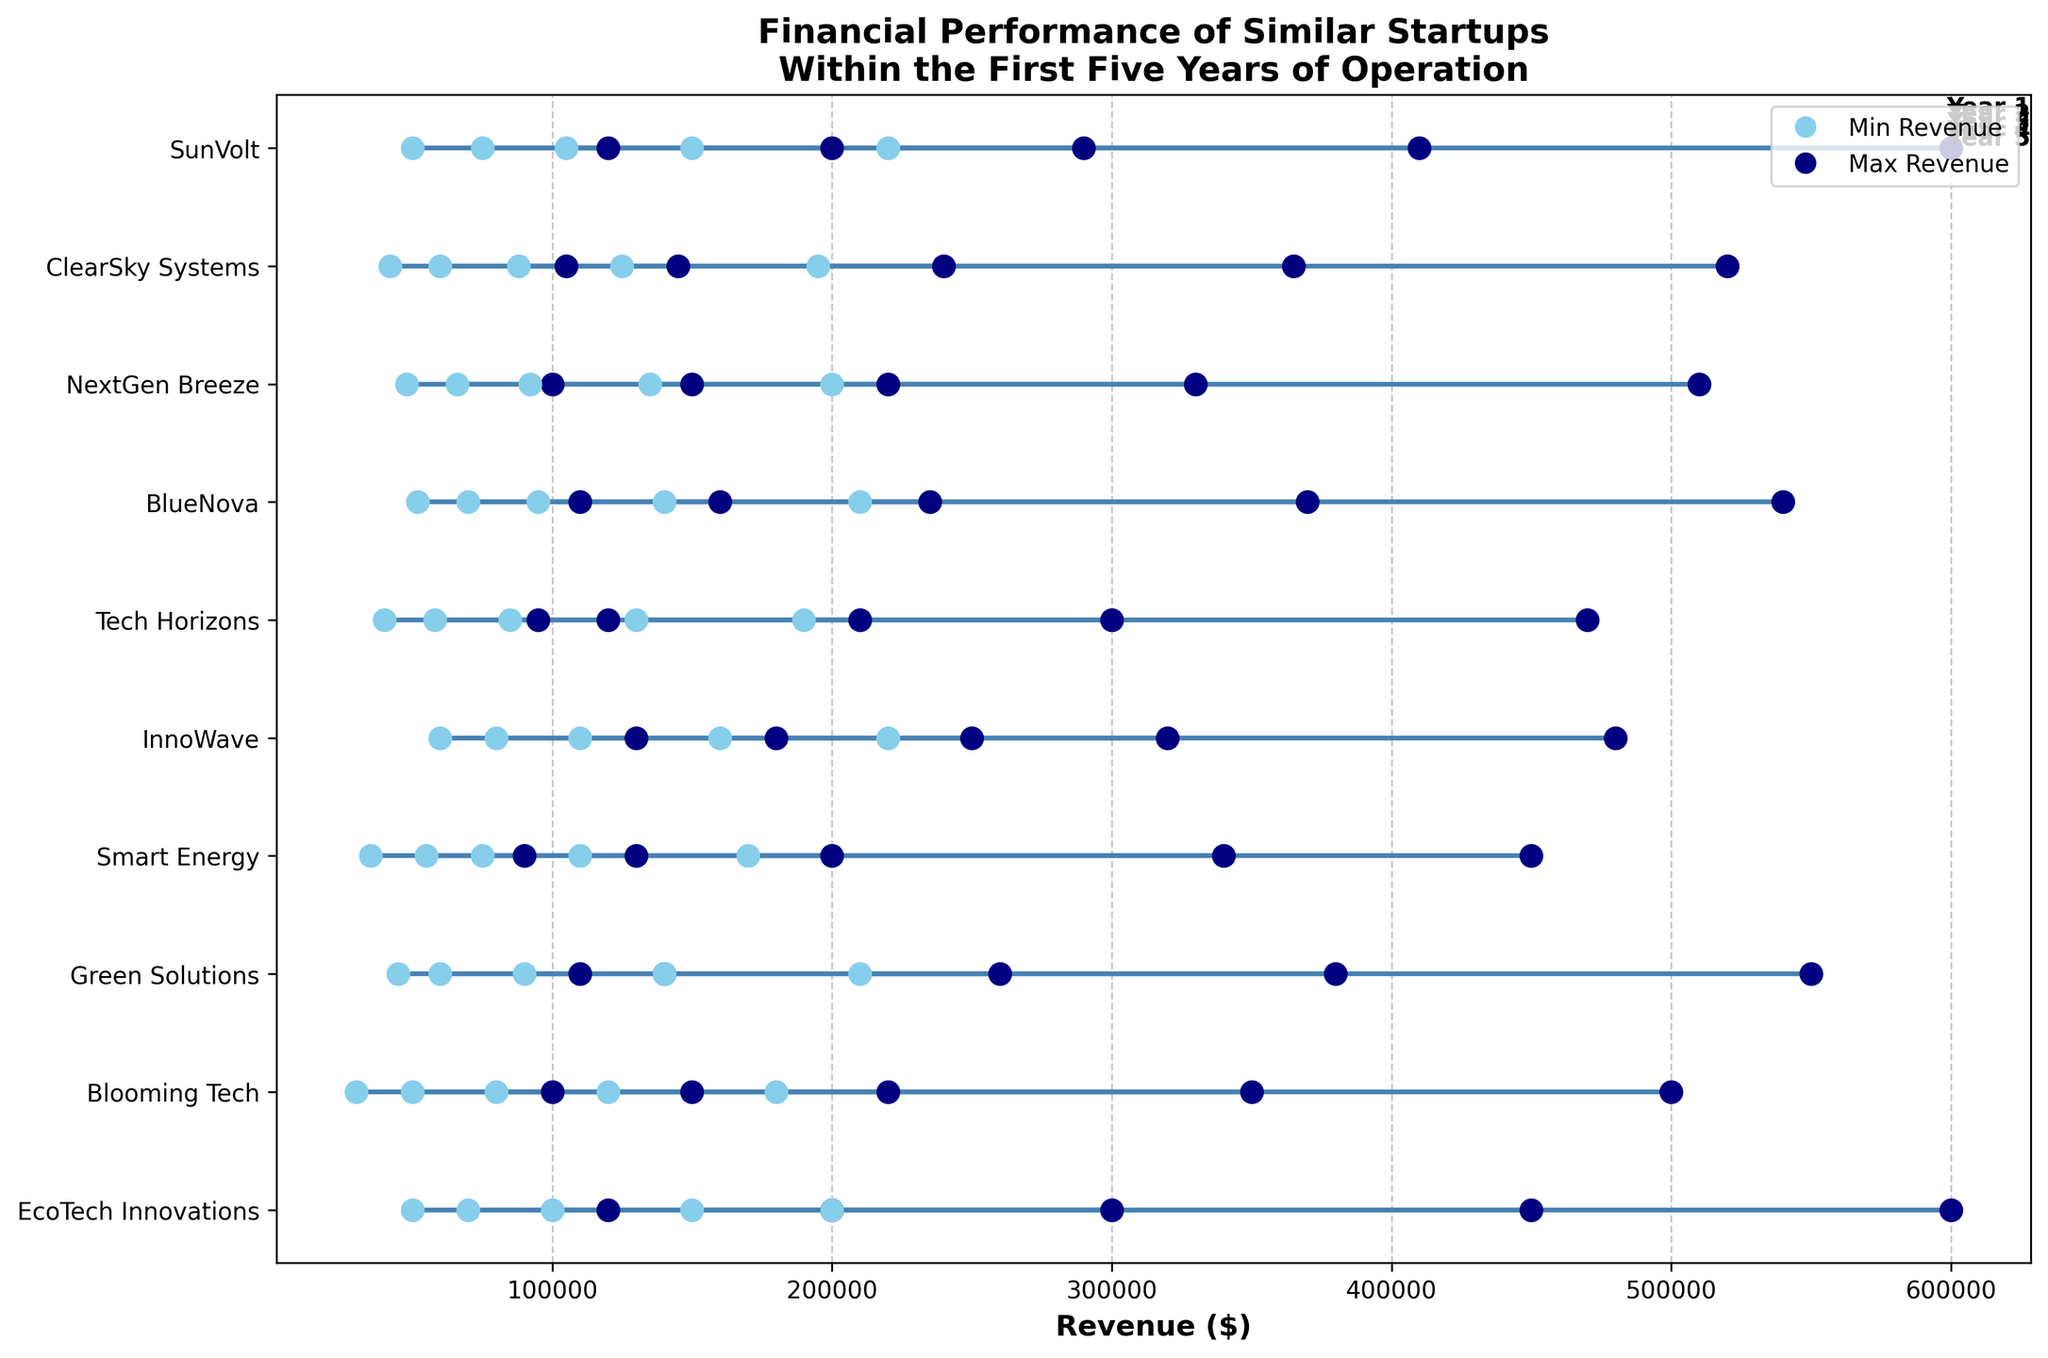what is the title of the plot? The title of the plot can be found at the top. It reads "Financial Performance of Similar Startups Within the First Five Years of Operation"
Answer: Financial Performance of Similar Startups Within the First Five Years of Operation Which startup has the highest range of revenue in Year 3? Look for the largest difference between the min and max dot placements in Year 3. For EcoTech Innovations, it ranges between $100,000 and $300,000. EcoTech Innovations has the highest range of $200,000.
Answer: EcoTech Innovations What is the minimum revenue of Smart Energy in Year 1? Identify the position of Smart Energy in the y-axis, then look for the smallest dot in Year 1 which is $35,000.
Answer: $35,000 Compare the maximum revenue in Year 2 for BlueNova and SunVolt. Which is higher? Look at Year 2 dots labeled for BlueNova and SunVolt, compare their maximum values. BlueNova has $160,000 while SunVolt has $200,000, so SunVolt has higher maximum revenue.
Answer: SunVolt Which startup had the smallest range of revenue in Year 4? Calculate the difference between min and max values for each startup in Year 4 and find the smallest. Tech Horizons has the range from $130,000 to $300,000, the difference is $170,000.
Answer: Tech Horizons What is the average max revenue in Year 5 across all startups? Sum the max revenues of all startups in Year 5 and divide by the number of startups (600,000 + 500,000 + 550,000 + 450,000 + 480,000 + 470,000 + 540,000 + 510,000 + 520,000 + 600,000) / 10 = 522,000)
Answer: $522,000 Which startups have a maximum revenue of $200,000 in Year 2? Locate startups with a point at the $200,000 level in Year 2. EcoTech Innovations and SunVolt both have that maximum revenue.
Answer: EcoTech Innovations, SunVolt 